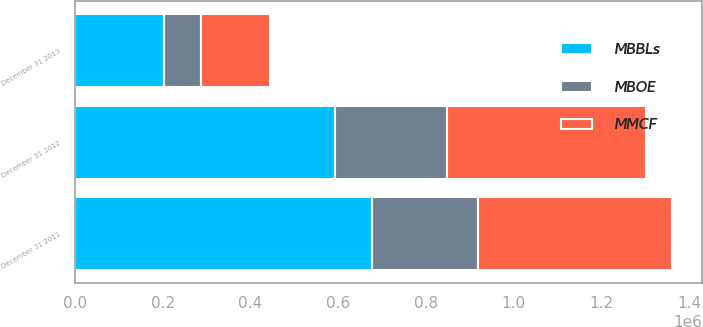Convert chart. <chart><loc_0><loc_0><loc_500><loc_500><stacked_bar_chart><ecel><fcel>December 31 2011<fcel>December 31 2012<fcel>December 31 2013<nl><fcel>MBOE<fcel>239799<fcel>256138<fcel>85467<nl><fcel>MBBLs<fcel>677675<fcel>592271<fcel>202674<nl><fcel>MMCF<fcel>443375<fcel>452789<fcel>156507<nl></chart> 